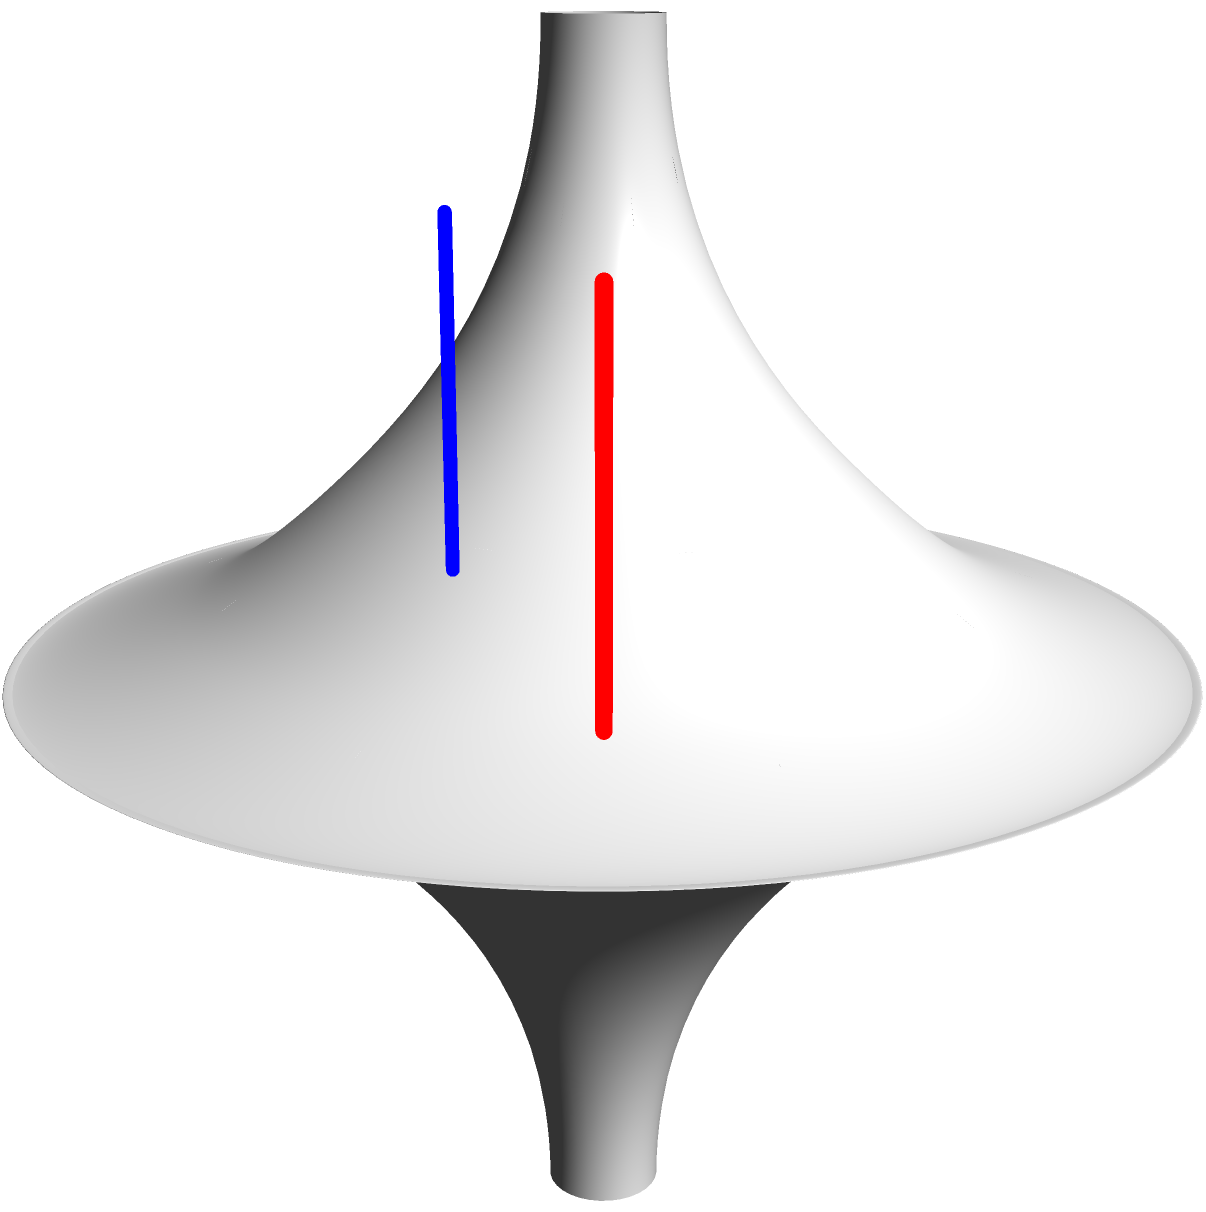In the context of a Korean drama set in a mathematics institute, two characters are discussing non-Euclidean geometry. They're examining parallel lines on a pseudosphere, similar to the image shown. If these lines were to extend indefinitely, what would happen to them, and how does this relate to the curvature of the surface? Let's break this down step-by-step:

1. The surface shown is a pseudosphere, which is a model of hyperbolic geometry.

2. In Euclidean geometry, parallel lines remain equidistant and never intersect.

3. However, on a pseudosphere:
   a. The surface has negative curvature.
   b. This negative curvature affects the behavior of geodesics (the shortest paths between two points on the surface).

4. On a pseudosphere:
   a. Initially parallel geodesics will diverge from each other as they extend.
   b. This is because the surface "flares out" towards its boundary.

5. The blue and red lines in the image represent two initially parallel geodesics.

6. As these lines extend towards the boundary of the pseudosphere:
   a. They will move farther apart from each other.
   b. This divergence is due to the negative curvature of the surface.

7. This behavior is in stark contrast to parallel lines on a sphere (positive curvature), which would converge.

8. The divergence of parallel lines is a key property of hyperbolic geometry, which is modeled by the pseudosphere.

This concept illustrates how the geometry of a surface can fundamentally change the behavior of lines and shapes drawn on it, showcasing the fascinating world of non-Euclidean geometry.
Answer: Parallel lines diverge due to negative curvature. 